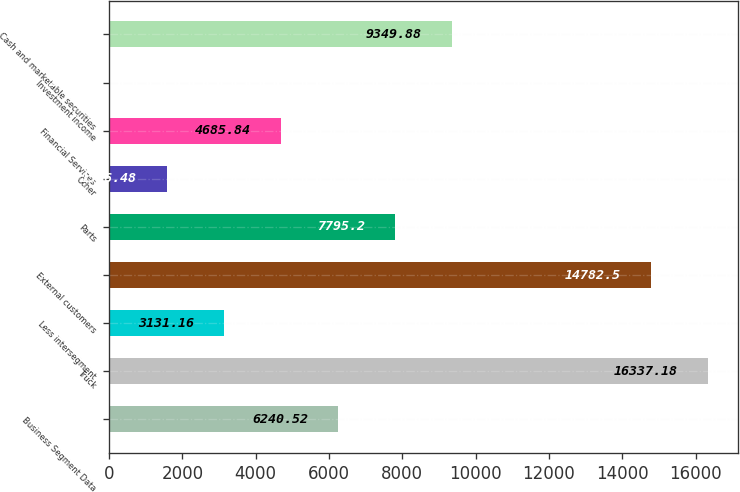<chart> <loc_0><loc_0><loc_500><loc_500><bar_chart><fcel>Business Segment Data<fcel>Truck<fcel>Less intersegment<fcel>External customers<fcel>Parts<fcel>Other<fcel>Financial Services<fcel>Investment income<fcel>Cash and marketable securities<nl><fcel>6240.52<fcel>16337.2<fcel>3131.16<fcel>14782.5<fcel>7795.2<fcel>1576.48<fcel>4685.84<fcel>21.8<fcel>9349.88<nl></chart> 